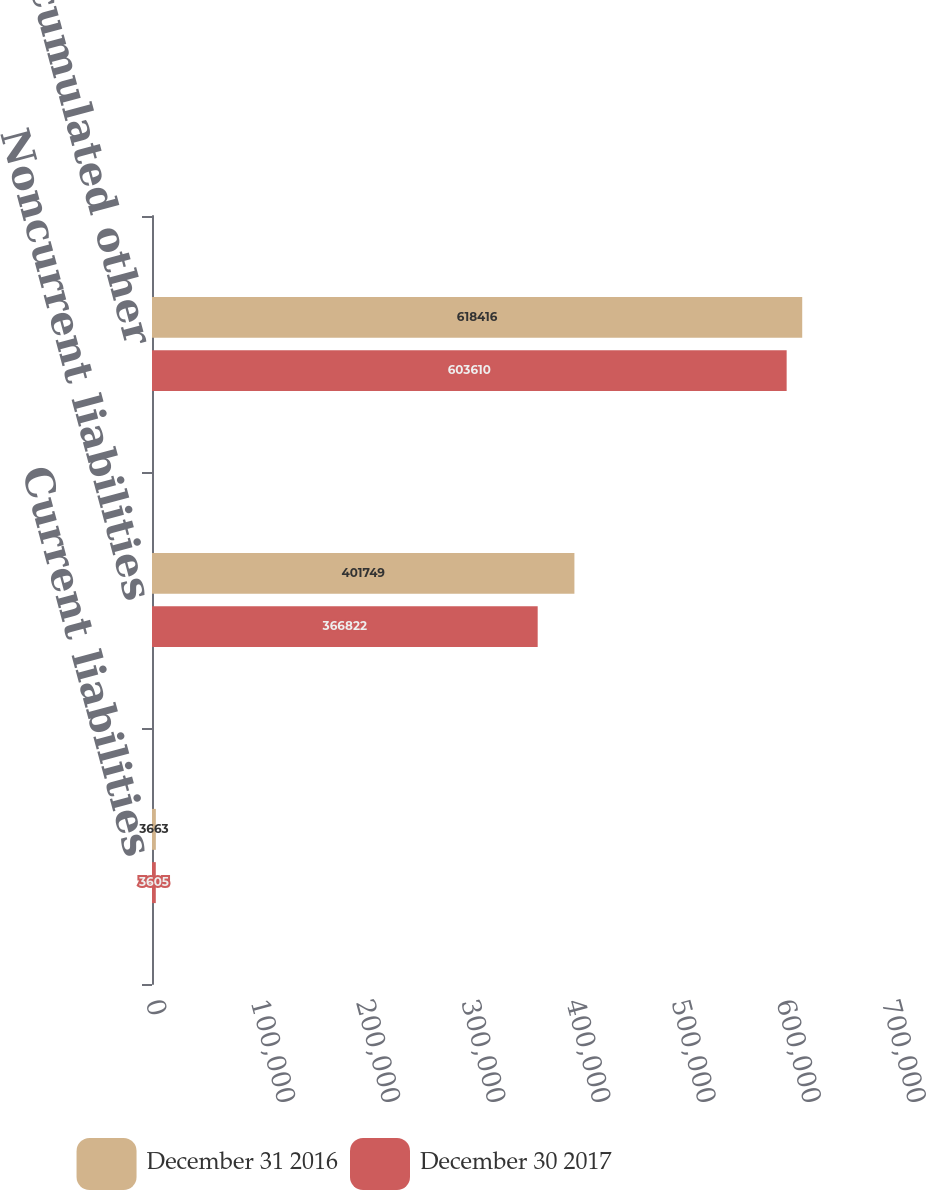Convert chart to OTSL. <chart><loc_0><loc_0><loc_500><loc_500><stacked_bar_chart><ecel><fcel>Current liabilities<fcel>Noncurrent liabilities<fcel>Accumulated other<nl><fcel>December 31 2016<fcel>3663<fcel>401749<fcel>618416<nl><fcel>December 30 2017<fcel>3605<fcel>366822<fcel>603610<nl></chart> 